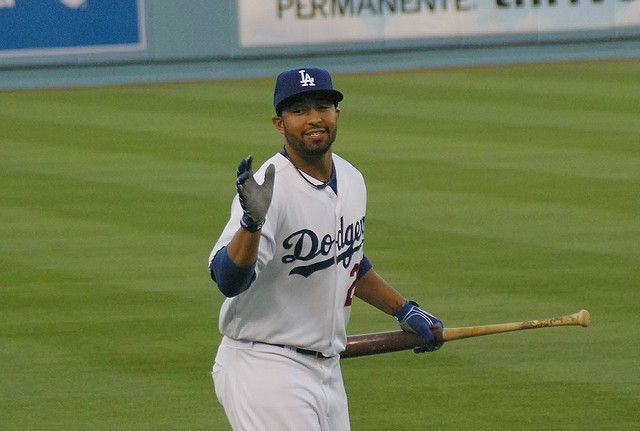Read all the text in this image. PERMANENTE 2 